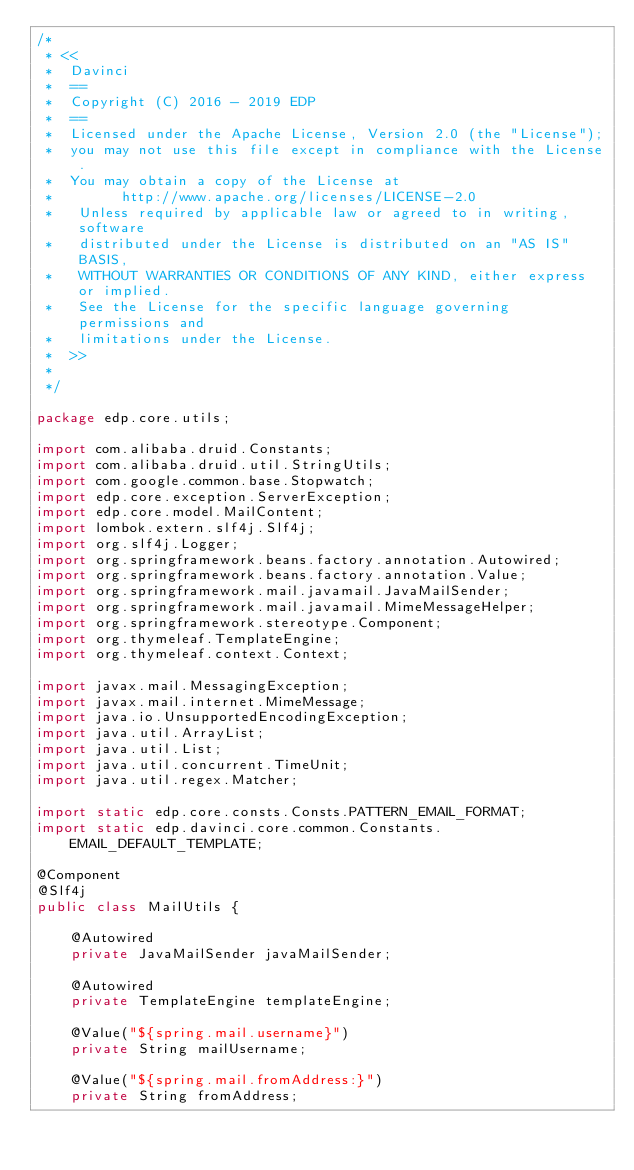Convert code to text. <code><loc_0><loc_0><loc_500><loc_500><_Java_>/*
 * <<
 *  Davinci
 *  ==
 *  Copyright (C) 2016 - 2019 EDP
 *  ==
 *  Licensed under the Apache License, Version 2.0 (the "License");
 *  you may not use this file except in compliance with the License.
 *  You may obtain a copy of the License at
 *        http://www.apache.org/licenses/LICENSE-2.0
 *   Unless required by applicable law or agreed to in writing, software
 *   distributed under the License is distributed on an "AS IS" BASIS,
 *   WITHOUT WARRANTIES OR CONDITIONS OF ANY KIND, either express or implied.
 *   See the License for the specific language governing permissions and
 *   limitations under the License.
 *  >>
 *
 */

package edp.core.utils;

import com.alibaba.druid.Constants;
import com.alibaba.druid.util.StringUtils;
import com.google.common.base.Stopwatch;
import edp.core.exception.ServerException;
import edp.core.model.MailContent;
import lombok.extern.slf4j.Slf4j;
import org.slf4j.Logger;
import org.springframework.beans.factory.annotation.Autowired;
import org.springframework.beans.factory.annotation.Value;
import org.springframework.mail.javamail.JavaMailSender;
import org.springframework.mail.javamail.MimeMessageHelper;
import org.springframework.stereotype.Component;
import org.thymeleaf.TemplateEngine;
import org.thymeleaf.context.Context;

import javax.mail.MessagingException;
import javax.mail.internet.MimeMessage;
import java.io.UnsupportedEncodingException;
import java.util.ArrayList;
import java.util.List;
import java.util.concurrent.TimeUnit;
import java.util.regex.Matcher;

import static edp.core.consts.Consts.PATTERN_EMAIL_FORMAT;
import static edp.davinci.core.common.Constants.EMAIL_DEFAULT_TEMPLATE;

@Component
@Slf4j
public class MailUtils {

    @Autowired
    private JavaMailSender javaMailSender;

    @Autowired
    private TemplateEngine templateEngine;

    @Value("${spring.mail.username}")
    private String mailUsername;

    @Value("${spring.mail.fromAddress:}")
    private String fromAddress;
</code> 